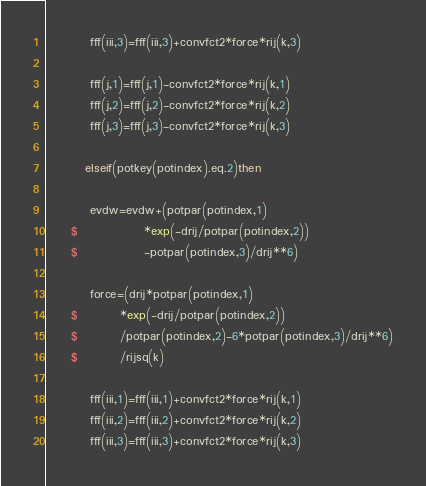<code> <loc_0><loc_0><loc_500><loc_500><_FORTRAN_>         fff(iii,3)=fff(iii,3)+convfct2*force*rij(k,3)

         fff(j,1)=fff(j,1)-convfct2*force*rij(k,1)
         fff(j,2)=fff(j,2)-convfct2*force*rij(k,2)
         fff(j,3)=fff(j,3)-convfct2*force*rij(k,3)

        elseif(potkey(potindex).eq.2)then

         evdw=evdw+(potpar(potindex,1)
     $              *exp(-drij/potpar(potindex,2))
     $              -potpar(potindex,3)/drij**6)

         force=(drij*potpar(potindex,1)
     $         *exp(-drij/potpar(potindex,2))
     $         /potpar(potindex,2)-6*potpar(potindex,3)/drij**6)
     $         /rijsq(k)

         fff(iii,1)=fff(iii,1)+convfct2*force*rij(k,1)
         fff(iii,2)=fff(iii,2)+convfct2*force*rij(k,2)
         fff(iii,3)=fff(iii,3)+convfct2*force*rij(k,3)
</code> 